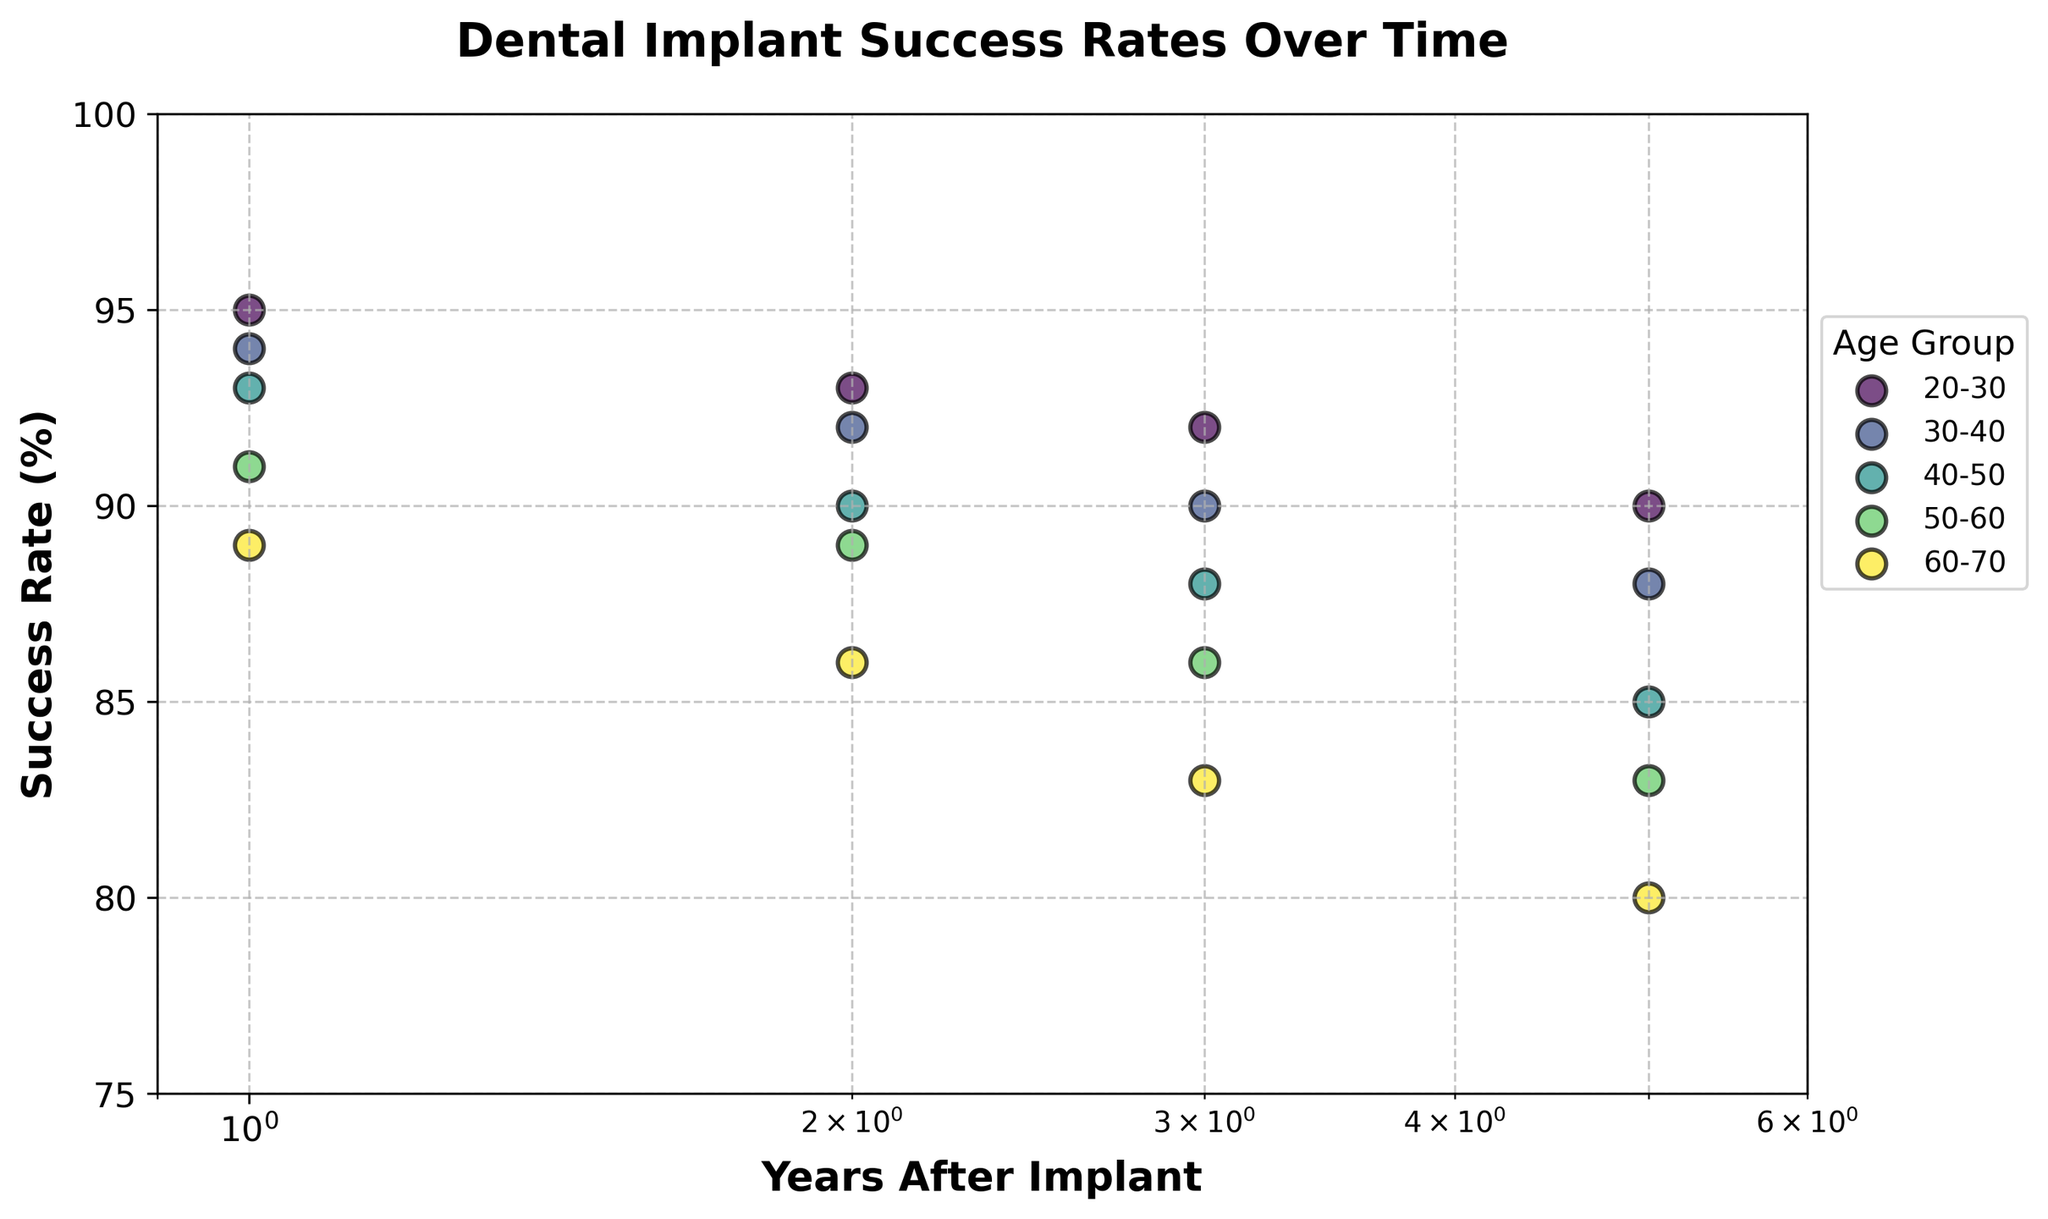What's the title of the plot? The title is usually located at the top of the plot and is prominently displayed. By reading it, one can quickly understand the main subject of the figure.
Answer: Dental Implant Success Rates Over Time What are the x-axis and y-axis labels? The x-axis and y-axis labels are descriptions of what each axis represents. These are typically found at the bottom of the x-axis and the left side of the y-axis, respectively.
Answer: Years After Implant (x-axis), Success Rate (%) (y-axis) How many age groups are represented in the plot? To determine the number of age groups, we count the distinct labels in the legend of the scatter plot. Each label corresponds to an age group.
Answer: Five What is the success rate for the 20-30 age group in year 1? Locate the data point for the 20-30 age group at 1 year on the x-axis and read the corresponding success rate on the y-axis.
Answer: 95 Which age group shows the highest success rate in the first year after the implant? Compare the y-values of the data points for each age group at year 1 (x=1), and find the highest value.
Answer: 20-30 How does the success rate change for the 60-70 age group over time? Observe the trend of the data points for the 60-70 age group by following the position from left (year 1) to right (year 5) and note the change in y-values.
Answer: Decreases Which age group has the steepest drop in success rate by year 5? Calculate the difference in success rates from year 1 to year 5 for each age group and identify the largest difference.
Answer: 60-70 On a log scale, what does a linear trend in the scatter plot indicate about the success rates? A linear trend on a log-scale axis indicates that the rate of decrease in success rates is proportional to the logarithm of time, implying a consistent decay rate over time.
Answer: Consistent decay rate How does the success rate for the 40-50 age group change between year 2 and year 5? Find the success rates at years 2 and 5 for the 40-50 age group and subtract the success rate at year 5 from the success rate at year 2.
Answer: Decreases by 5% Which age group maintains a success rate above 85% throughout the entire time period? Identify the age group(s) whose data points on the y-axis remain above 85% from year 1 to year 5.
Answer: 20-30 